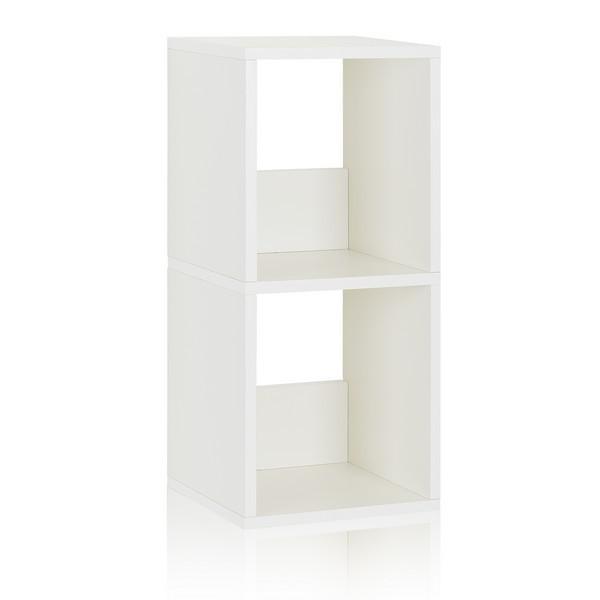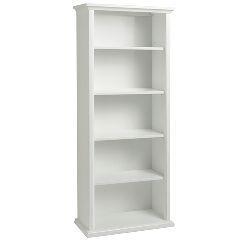The first image is the image on the left, the second image is the image on the right. Examine the images to the left and right. Is the description "Two boxy white bookcases are different sizes, one of them with exactly three shelves and the other with two." accurate? Answer yes or no. No. The first image is the image on the left, the second image is the image on the right. Considering the images on both sides, is "In the left image, there's a bookcase with a single shelf angled toward the right." valid? Answer yes or no. Yes. 